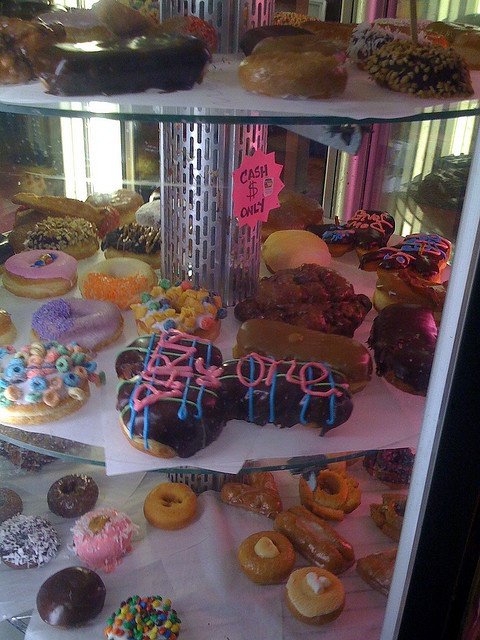Describe the objects in this image and their specific colors. I can see donut in black, maroon, and gray tones, donut in black, maroon, and purple tones, donut in black, brown, gray, and maroon tones, donut in black and gray tones, and donut in black, olive, gray, and maroon tones in this image. 